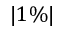<formula> <loc_0><loc_0><loc_500><loc_500>| 1 \% |</formula> 